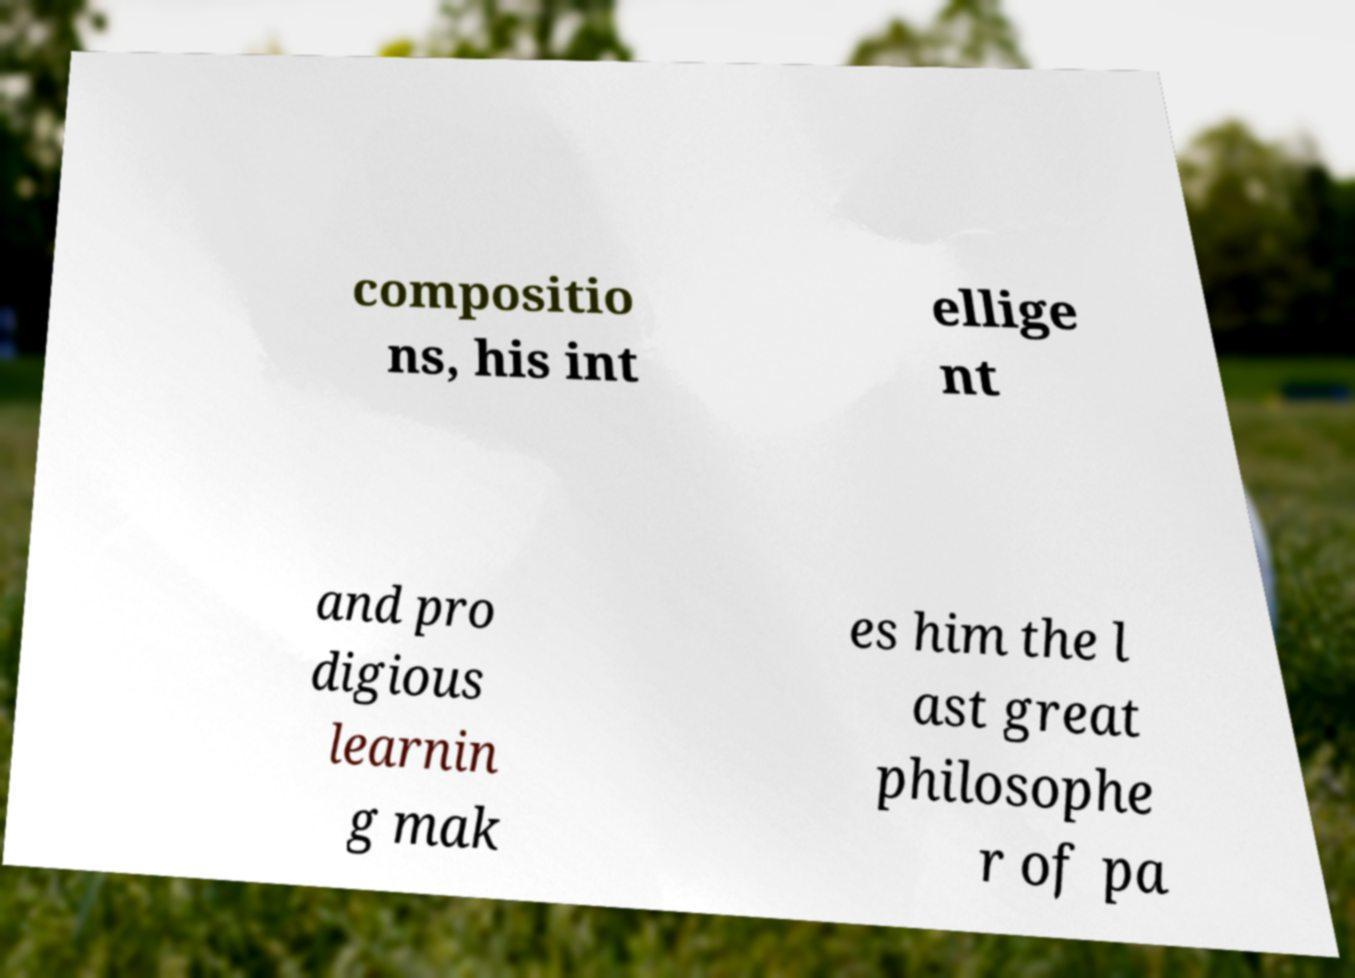Please identify and transcribe the text found in this image. compositio ns, his int ellige nt and pro digious learnin g mak es him the l ast great philosophe r of pa 